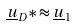<formula> <loc_0><loc_0><loc_500><loc_500>\underline { u } _ { D } * \approx \underline { u } _ { 1 }</formula> 